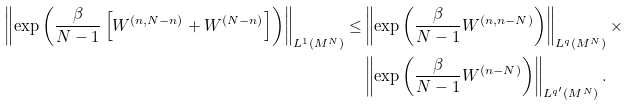<formula> <loc_0><loc_0><loc_500><loc_500>\left \| \exp { \left ( \frac { \beta } { N - 1 } \left [ W ^ { ( n , N - n ) } + W ^ { ( N - n ) } \right ] \right ) } \right \| _ { L ^ { 1 } ( M ^ { N } ) } \leq & \left \| \exp { \left ( \frac { \beta } { N - 1 } W ^ { ( n , n - N ) } \right ) } \right \| _ { L ^ { q } ( M ^ { N } ) } \times \\ & \left \| \exp { \left ( \frac { \beta } { N - 1 } W ^ { ( n - N ) } \right ) } \right \| _ { L ^ { q ^ { \prime } } ( M ^ { N } ) } .</formula> 